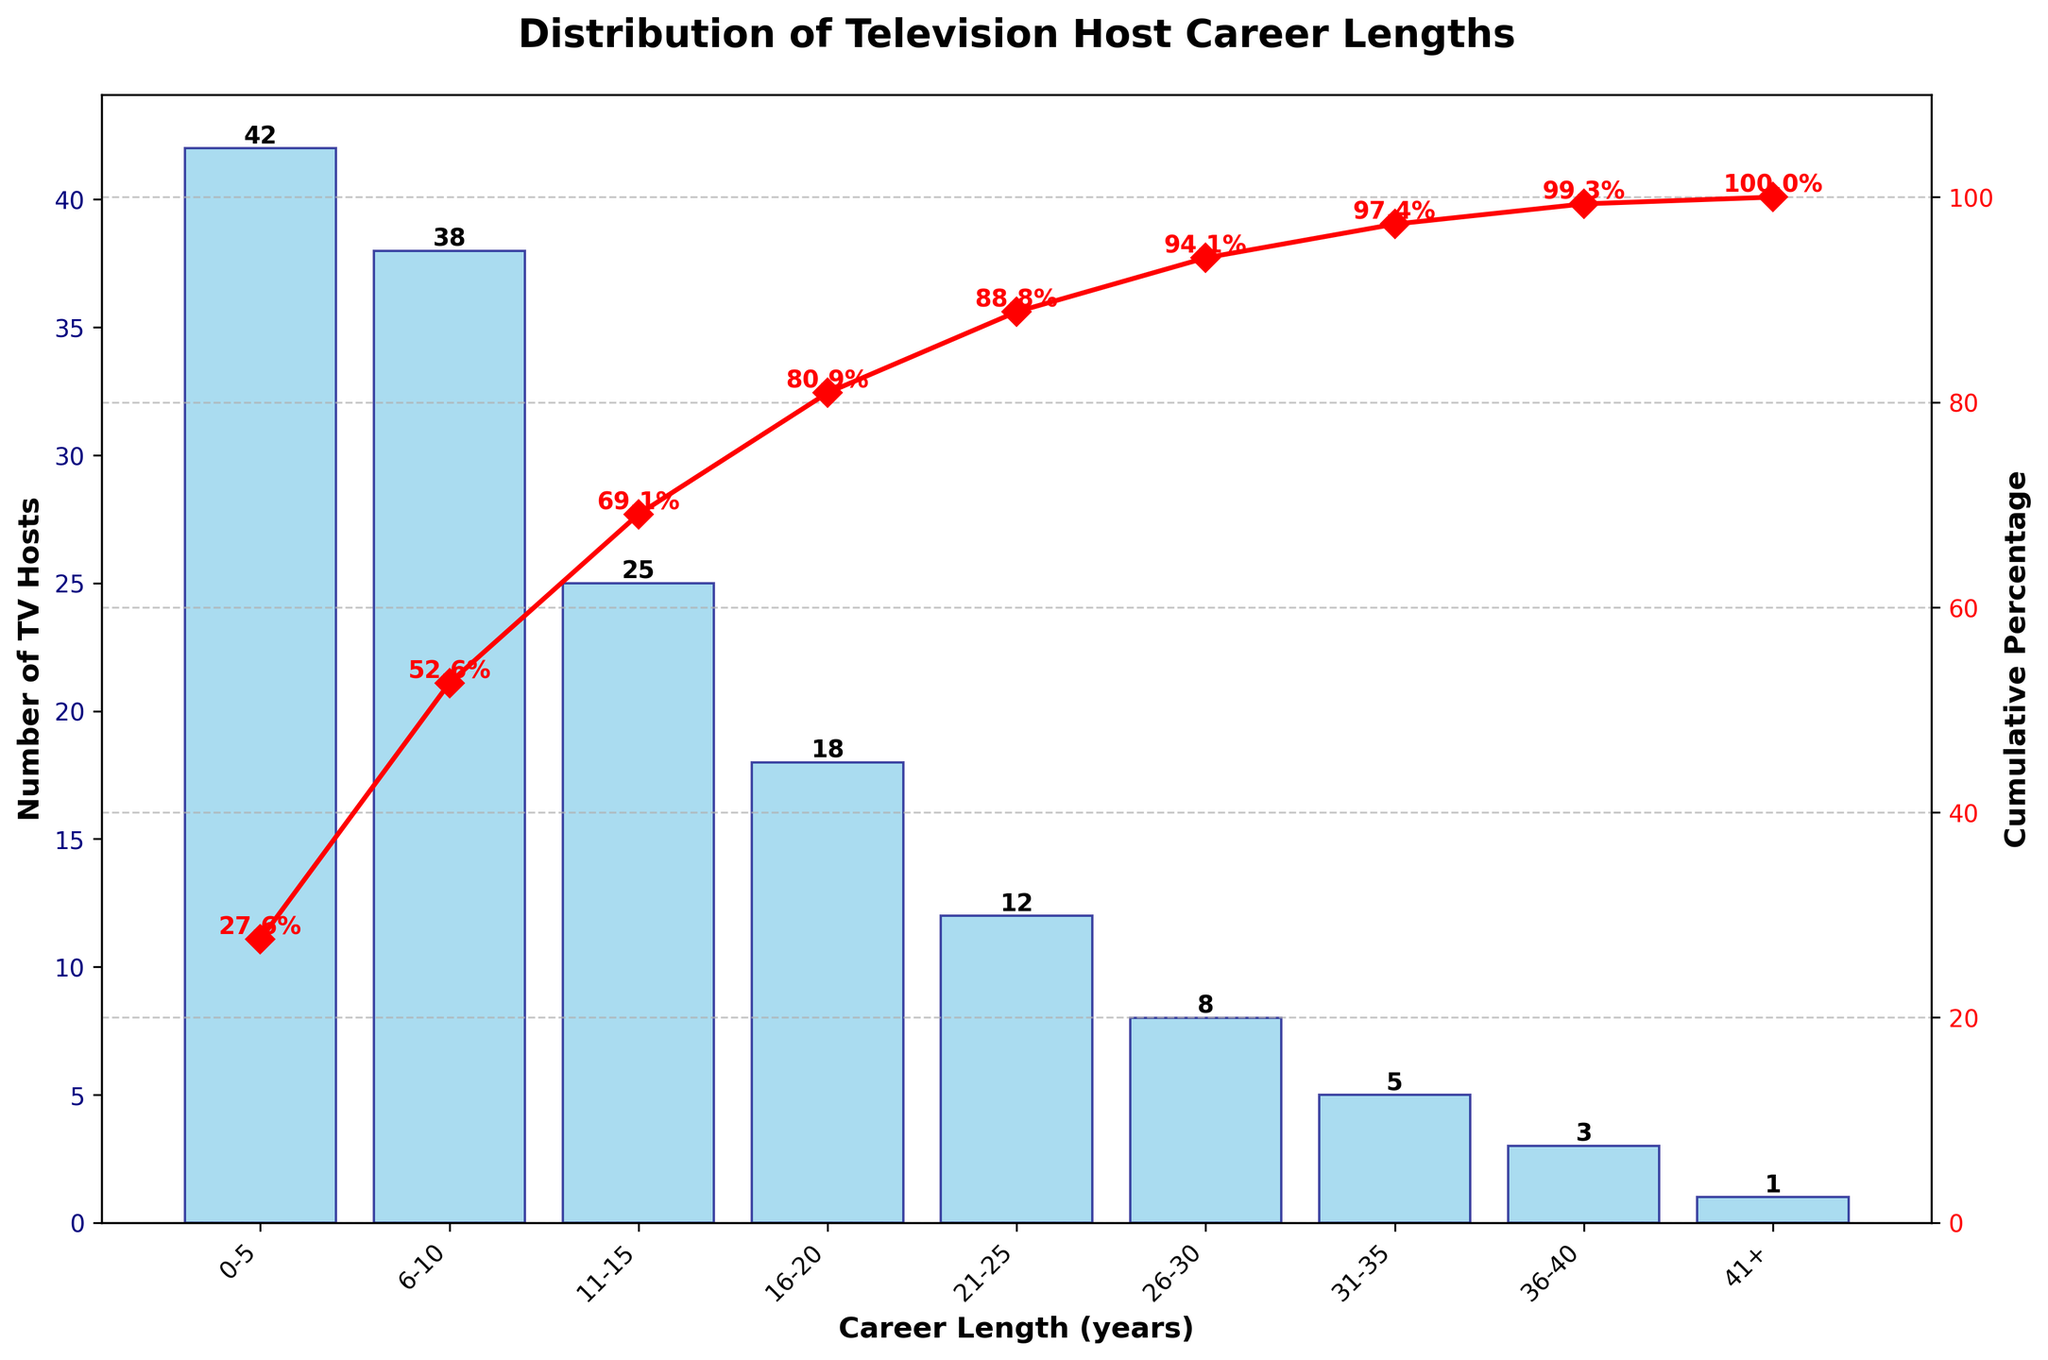What is the title of the chart? The title of the chart is displayed at the top and reads "Distribution of Television Host Career Lengths".
Answer: Distribution of Television Host Career Lengths Which career length category has the highest number of TV hosts? The tallest bar on the chart corresponds to the "0-5" years category, indicating it has the highest number of TV hosts.
Answer: 0-5 How many TV hosts have a career length of 21-25 years? Refer to the bar labeled "21-25" years; the number shown above it indicates the count of TV hosts is 12.
Answer: 12 What percentage of TV hosts have careers of 10 years or less? Add the number of TV hosts from the "0-5" and "6-10" categories and then calculate their percentage from the total. (42 + 38) / 152 * 100 ≈ 52.6%.
Answer: 52.6% How does the cumulative percentage change from the "11-15" to the "16-20" career length categories? The cumulative percentage at "11-15" years is around 69% and at "16-20" years it is around 81%. Subtracting these gives the change: 81% - 69% = 12%.
Answer: 12% Which career length category has the lowest number of TV hosts? The shortest bar on the chart represents the "41+" years category, showing that it has the lowest number of TV hosts.
Answer: 41+ How many TV hosts have careers of more than 20 years? Add the number of TV hosts from the categories above "20" years: (12 + 8 + 5 + 3 + 1) = 29.
Answer: 29 Which career length category marks the approximate 80% cumulative percentage point? The corresponding cumulative percentage line intersects around the "16-20" years category, showing it approximates the 80% mark.
Answer: 16-20 Compare the total number of TV hosts in the "0-10" years categories to those in the "11-20" years categories. Sum the number of TV hosts in "0-5" and "6-10" categories (42 + 38 = 80) and "11-15" and "16-20" categories (25 + 18 = 43). The "0-10" categories have more hosts (80 > 43).
Answer: 80 vs 43 How many career length categories are displayed on the chart? Count the distinct labels on the x-axis; there are nine categories displayed.
Answer: 9 